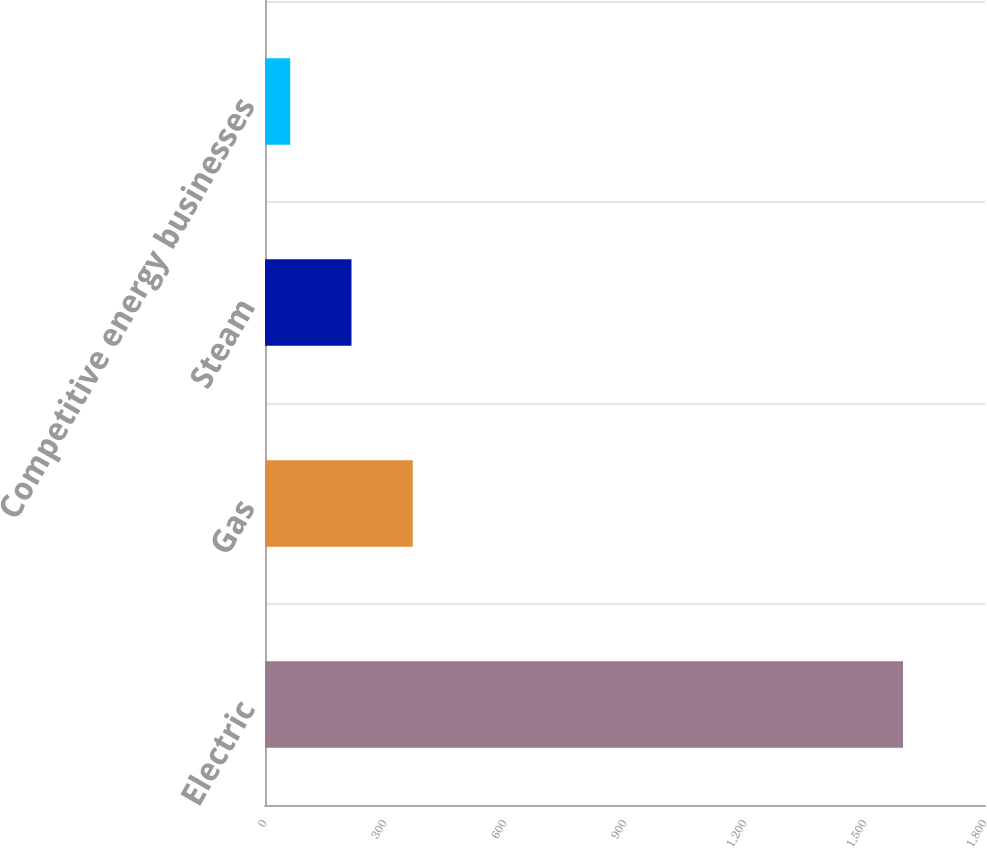Convert chart. <chart><loc_0><loc_0><loc_500><loc_500><bar_chart><fcel>Electric<fcel>Gas<fcel>Steam<fcel>Competitive energy businesses<nl><fcel>1595<fcel>369.4<fcel>216.2<fcel>63<nl></chart> 